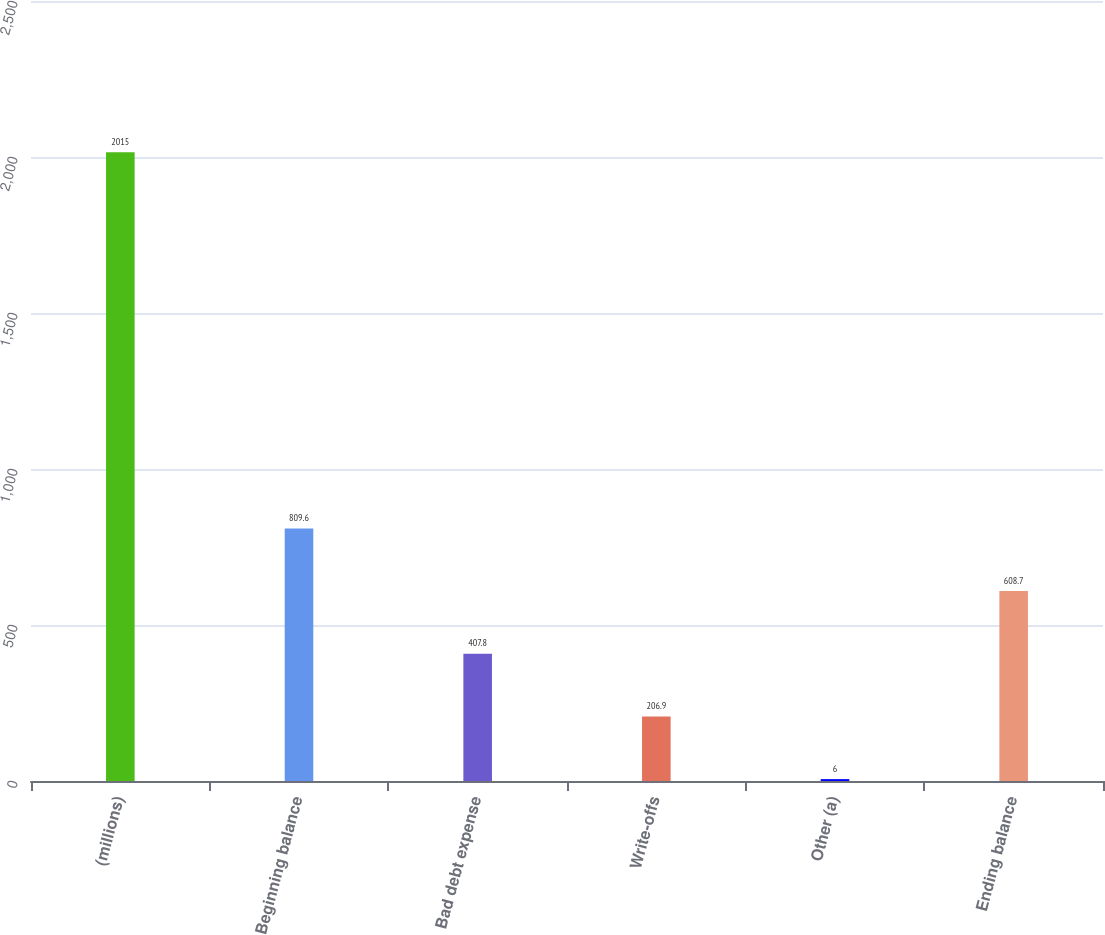<chart> <loc_0><loc_0><loc_500><loc_500><bar_chart><fcel>(millions)<fcel>Beginning balance<fcel>Bad debt expense<fcel>Write-offs<fcel>Other (a)<fcel>Ending balance<nl><fcel>2015<fcel>809.6<fcel>407.8<fcel>206.9<fcel>6<fcel>608.7<nl></chart> 